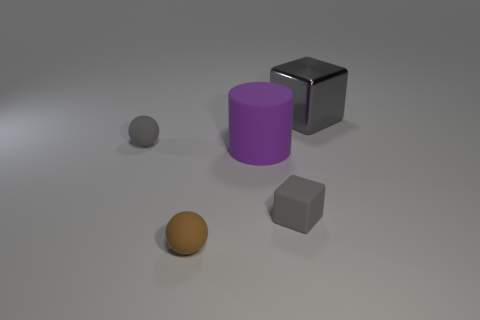Add 1 big green cubes. How many objects exist? 6 Subtract all cylinders. How many objects are left? 4 Add 2 big purple cylinders. How many big purple cylinders exist? 3 Subtract 0 yellow blocks. How many objects are left? 5 Subtract all big purple rubber cylinders. Subtract all large blue shiny cubes. How many objects are left? 4 Add 5 big rubber cylinders. How many big rubber cylinders are left? 6 